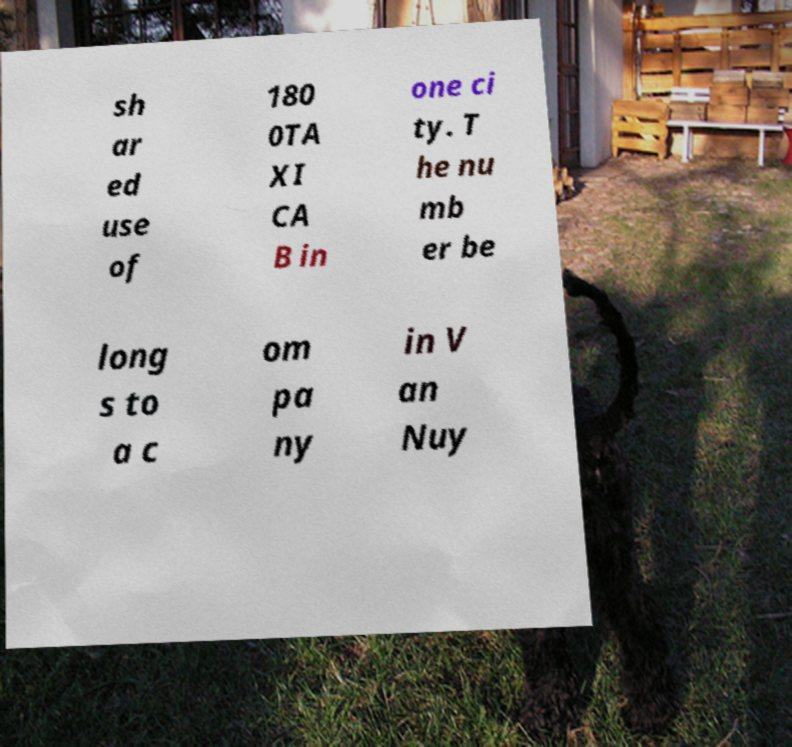Could you assist in decoding the text presented in this image and type it out clearly? sh ar ed use of 180 0TA XI CA B in one ci ty. T he nu mb er be long s to a c om pa ny in V an Nuy 